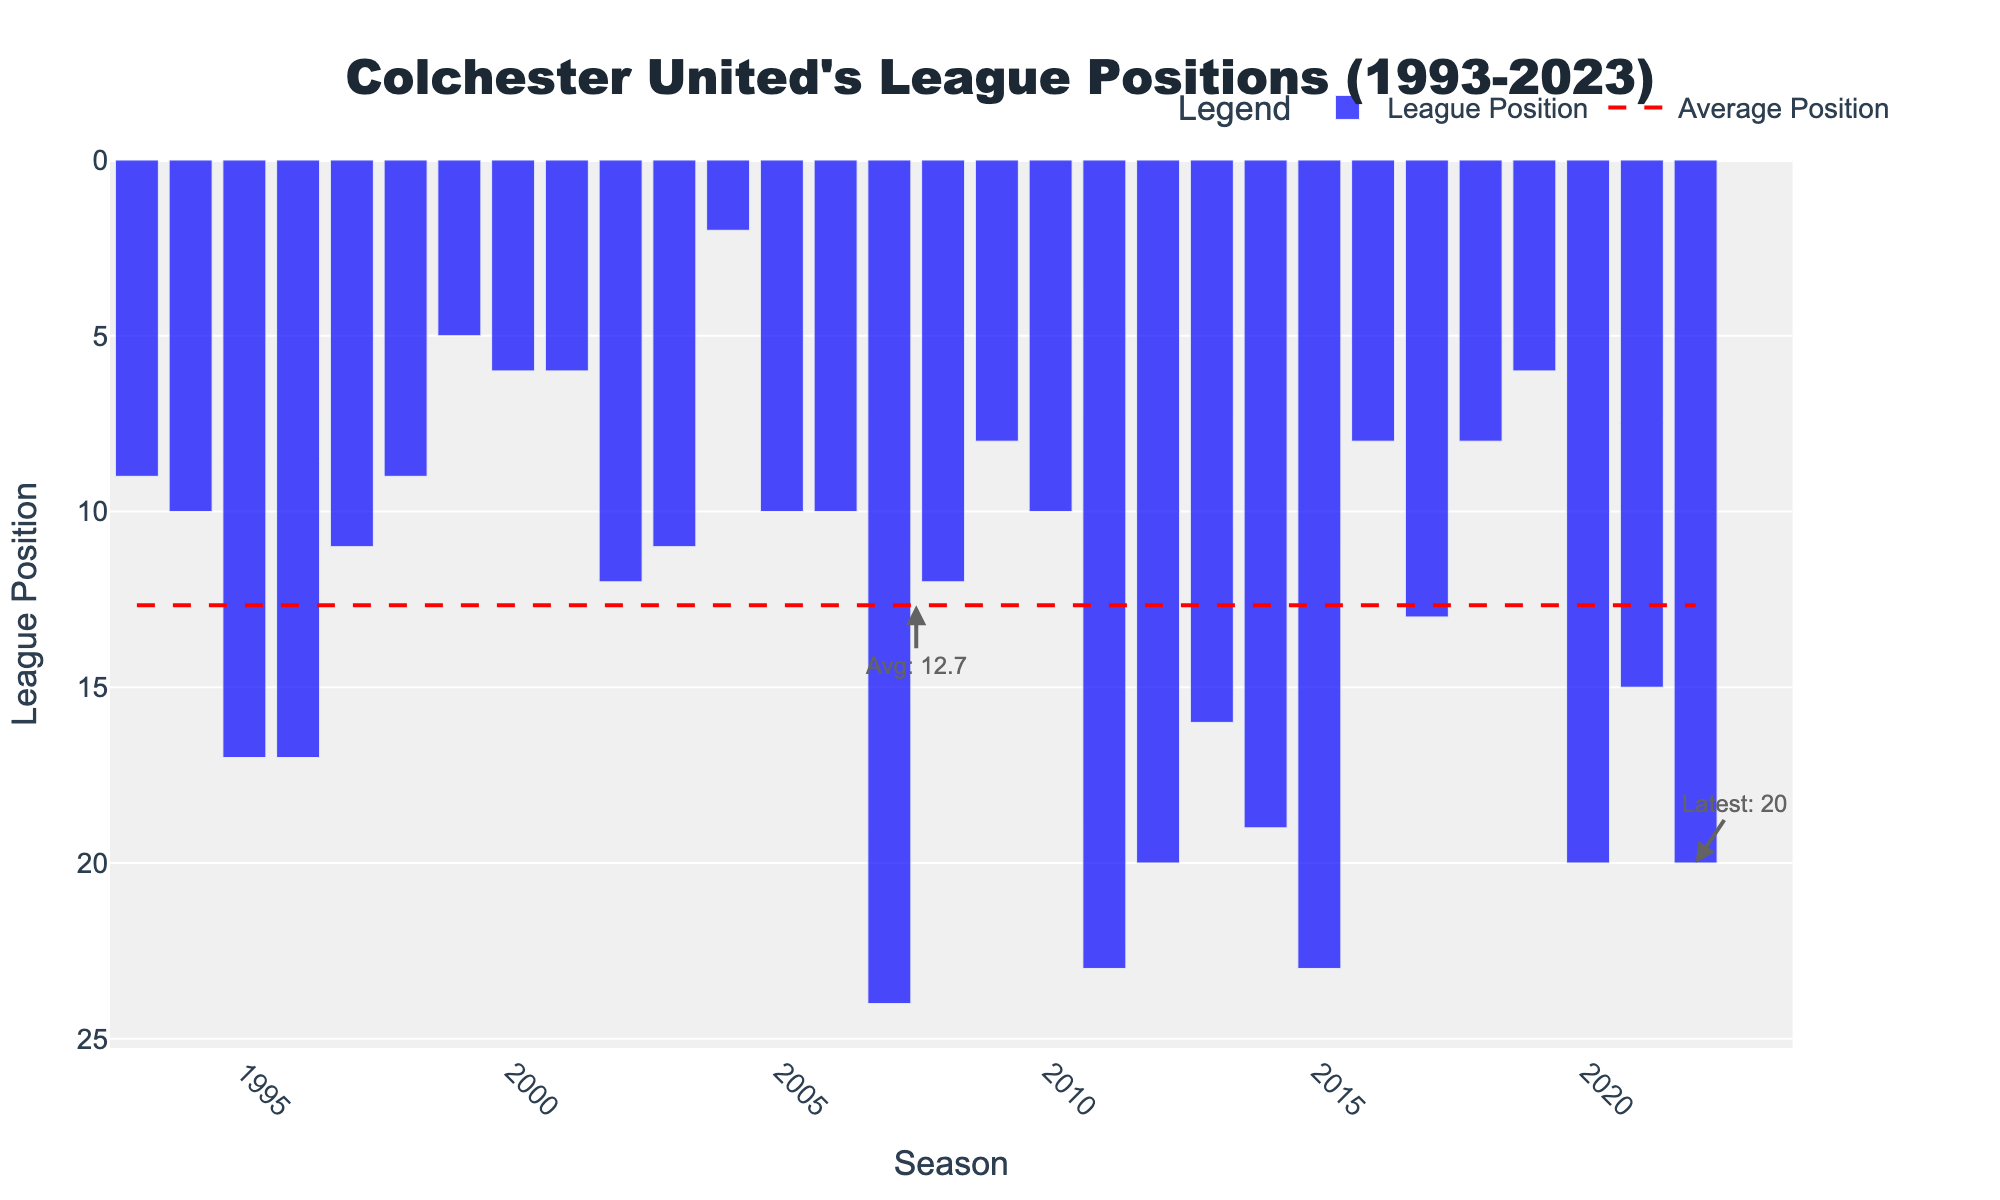What season had the highest league position between 1993 and 2023? The highest league position corresponds to the lowest numerical value on the vertical axis. Scanning the chart, the lowest position is '2' in the 2004-05 season.
Answer: 2004-05 How many seasons did Colchester United finish above their average league position? To determine the number of seasons above average, we first note the average position line (red dashed). By counting how many bars (blue bars) fall below this line, we see there are 13 such seasons.
Answer: 13 Which season showed the biggest drop in league position compared to the previous season? Identify the vertical drops between consecutive bars. The most significant drop is from '10' in 2006-07 to '24' in 2007-08, a difference of 14 positions.
Answer: 2007-08 In which seasons did Colchester United end up in 6th position? Looking at the heights of the bars marked '6,' and referring to the axis for specific years, these seasons are 2000-01, 2001-02, and 2019-20.
Answer: 2000-01, 2001-02, 2019-20 What's the trend of the league positions over the earliest 5 seasons (1993-1998)? Observe the heights of the bars for the first five seasons: 9, 10, 17, 17, and 11. The league positions trend downward initially, rising again in the fourth and fifth seasons.
Answer: Down, then up Comparing 2007-08 and 2011-12, which season had a worse league position? Find and compare the heights of the bars for both seasons; '24' in 2007-08 and '23' in 2011-12. '24' is worse than '23'.
Answer: 2007-08 What is the average league position marked by the red dashed line? The average league position is indicated by the red dashed line on the chart. From an annotation, it is marked as approximately 13.3.
Answer: 13.3 How does the 2022-23 season league position compare to the initial 1993-94 season? Compare the heights of the bars for both seasons—the initial is '9' and the latest is '20'. The latter position is worse.
Answer: Worse How many seasons did Colchester United finish in the top 10? Count all the instances where the bar is at or below the '10' mark. There are nine such seasons.
Answer: 9 Which season had the most significant improvement in league position? Find the largest leap upward from one season to the next. The leap from '23' in 2015-16 to '8' in 2016-17 is the largest, an improvement of 15 positions.
Answer: 2016-17 